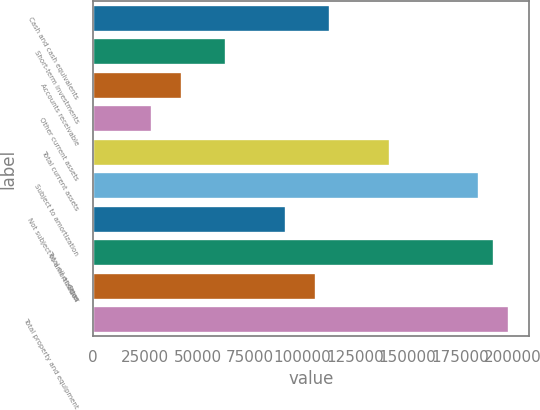Convert chart to OTSL. <chart><loc_0><loc_0><loc_500><loc_500><bar_chart><fcel>Cash and cash equivalents<fcel>Short-term investments<fcel>Accounts receivable<fcel>Other current assets<fcel>Total current assets<fcel>Subject to amortization<fcel>Not subject to amortization<fcel>Total oil and gas<fcel>Other<fcel>Total property and equipment<nl><fcel>113218<fcel>63702.4<fcel>42481.6<fcel>28334.4<fcel>141512<fcel>183954<fcel>91996.8<fcel>191027<fcel>106144<fcel>198101<nl></chart> 